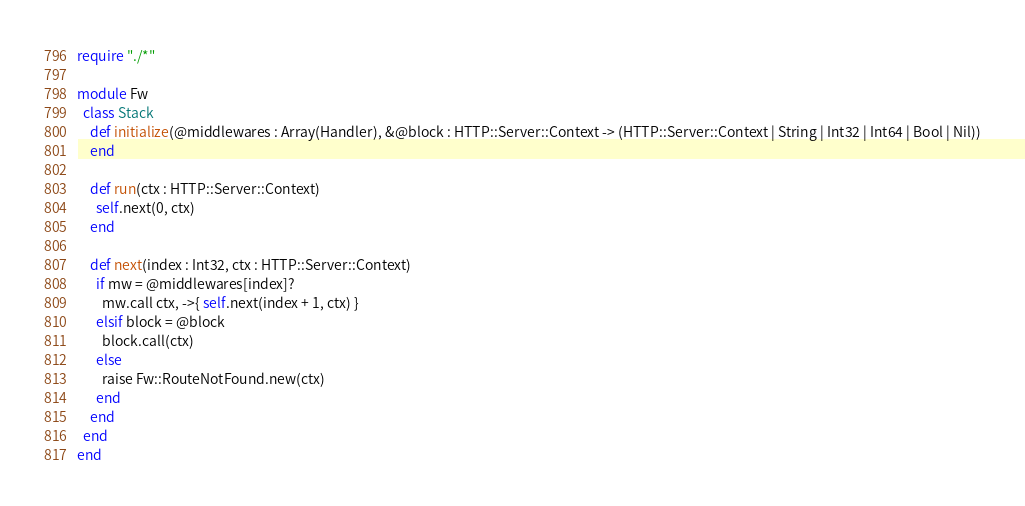Convert code to text. <code><loc_0><loc_0><loc_500><loc_500><_Crystal_>require "./*"

module Fw
  class Stack    
    def initialize(@middlewares : Array(Handler), &@block : HTTP::Server::Context -> (HTTP::Server::Context | String | Int32 | Int64 | Bool | Nil))
    end
    
    def run(ctx : HTTP::Server::Context)
      self.next(0, ctx)
    end
    
    def next(index : Int32, ctx : HTTP::Server::Context)
      if mw = @middlewares[index]?
        mw.call ctx, ->{ self.next(index + 1, ctx) }
      elsif block = @block
        block.call(ctx)
      else
        raise Fw::RouteNotFound.new(ctx)
      end
    end
  end
end
</code> 